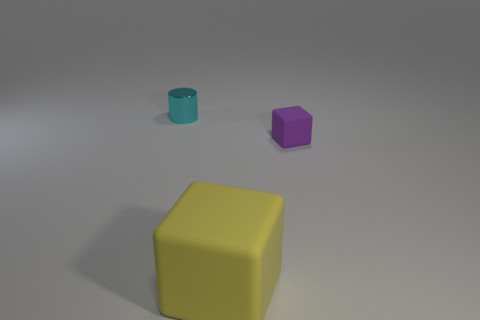Subtract 2 blocks. How many blocks are left? 0 Subtract all blocks. How many objects are left? 1 Subtract 0 cyan balls. How many objects are left? 3 Subtract all yellow cylinders. Subtract all gray cubes. How many cylinders are left? 1 Subtract all blue cylinders. How many gray cubes are left? 0 Subtract all large yellow things. Subtract all cyan cylinders. How many objects are left? 1 Add 3 tiny cyan things. How many tiny cyan things are left? 4 Add 1 small cyan things. How many small cyan things exist? 2 Add 2 yellow objects. How many objects exist? 5 Subtract all purple cubes. How many cubes are left? 1 